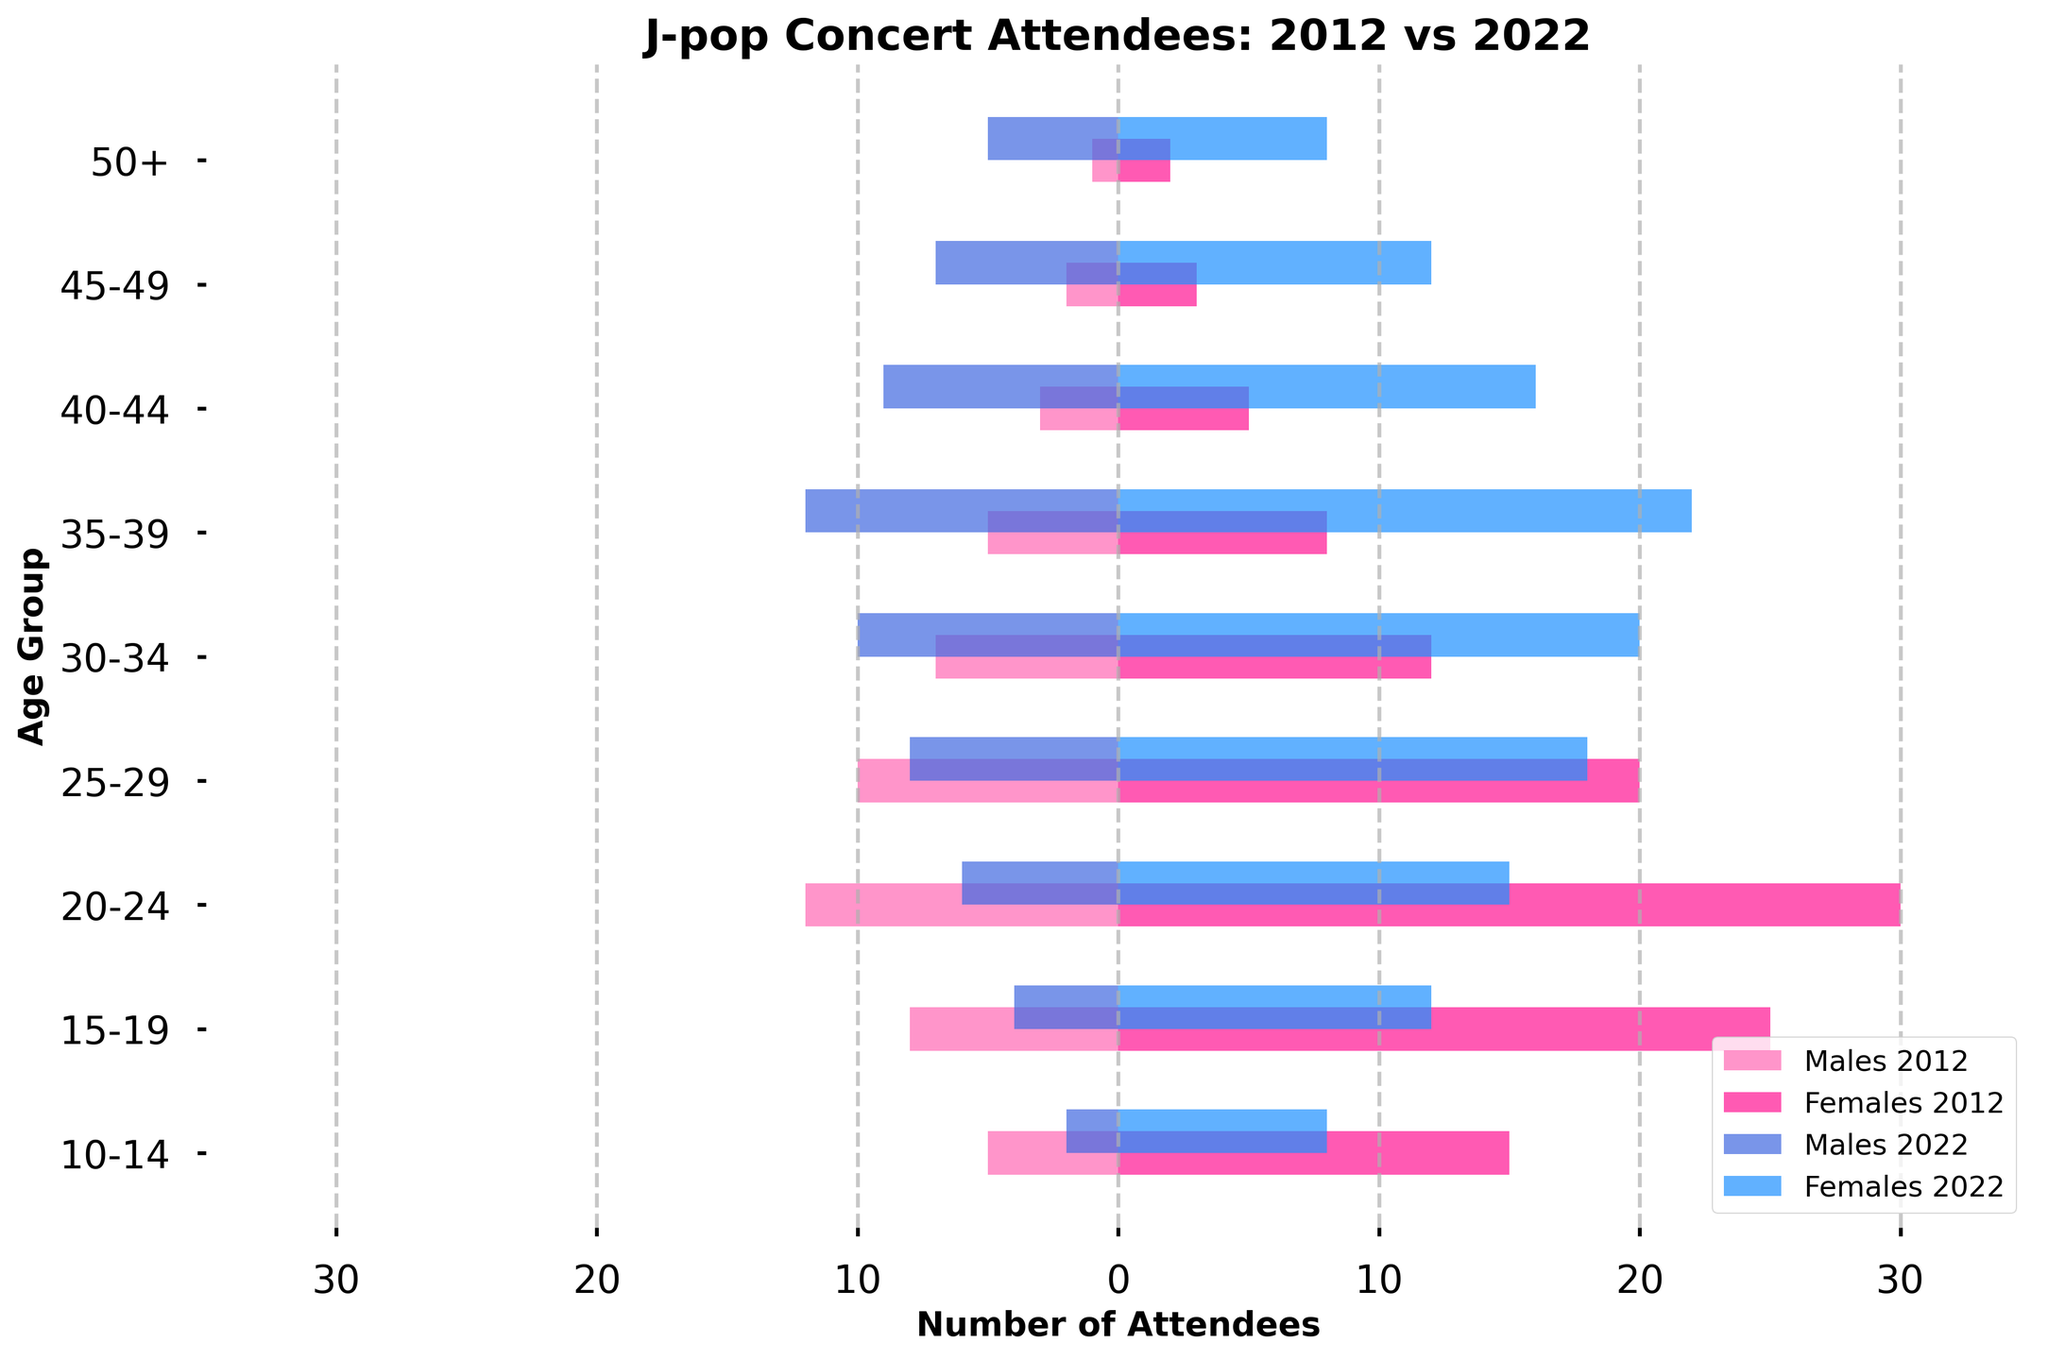Which age group had the highest number of female attendees in 2022? The highest bar on the right side in 2022 for females corresponds to the 35-39 age group.
Answer: 35-39 How did the number of male attendees aged 25-29 change from 2012 to 2022? Look at the length of the bars for males in the 25-29 age group: in 2012 it's 10, in 2022 it's 8. The number decreased by 2.
Answer: Decreased by 2 Which age group saw the greatest increase in female attendees from 2012 to 2022? Compare the length of the bars for females in each age group between 2012 and 2022. The 35-39 age group increased the most, from 8 to 22.
Answer: 35-39 What is the total number of attendees aged 20-24 in 2022? Sum the lengths of the bars for both males and females in the 20-24 age group in 2022: 6 (males) + 15 (females) = 21.
Answer: 21 How many more males attended in the 40-44 age group in 2022 compared to 2012? Check the length of the bars for males in the 40-44 age group: in 2012 it's 3, in 2022 it's 9. The difference is 6.
Answer: 6 Which gender and age group combination had the lowest number of attendees in 2012? Look for the smallest bar for both genders in 2012. The lowest is males in the 50+ age group with 1 attendee.
Answer: Males 50+ Compare the number of male attendees aged 30-34 in 2012 with female attendees in the same age group in 2022. Which is higher? The bar lengths show that males in 2012 is 7 and females in 2022 is 20. Females in 2022 is higher.
Answer: Females 2022 What is the difference in female attendees between 2012 and 2022 for the 15-19 age group? Look at the bar lengths for females in the 15-19 age group: in 2012 it's 25, in 2022 it's 12. The difference is 13 fewer attendees.
Answer: 13 fewer Which age group saw a decline in both male and female attendees from 2012 to 2022? Check each age group: the 15-19 age group declined for both genders (males from 8 to 4, females from 25 to 12).
Answer: 15-19 